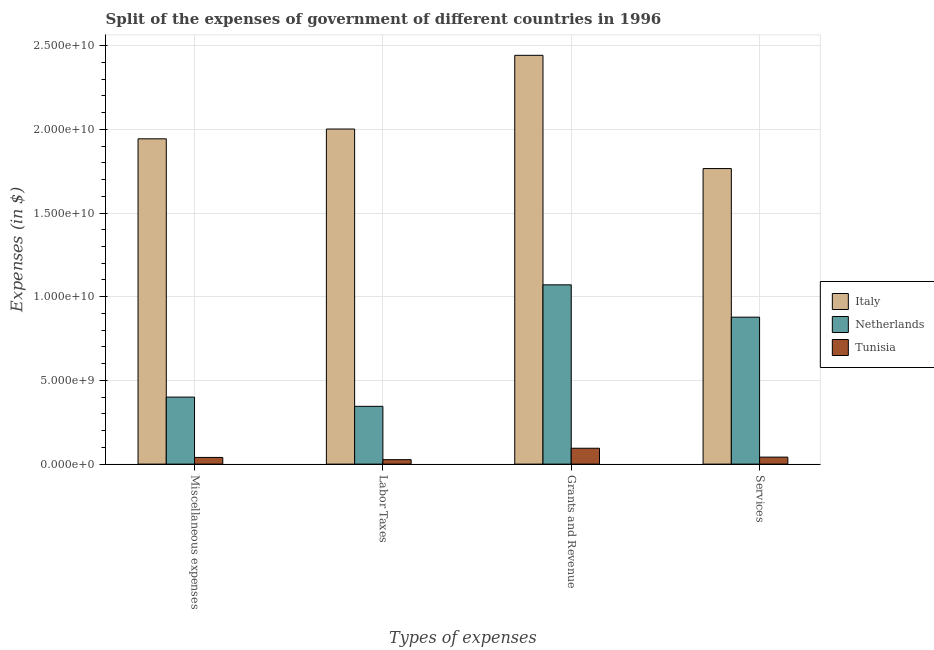Are the number of bars on each tick of the X-axis equal?
Give a very brief answer. Yes. What is the label of the 3rd group of bars from the left?
Your answer should be compact. Grants and Revenue. What is the amount spent on services in Italy?
Offer a terse response. 1.77e+1. Across all countries, what is the maximum amount spent on labor taxes?
Offer a terse response. 2.00e+1. Across all countries, what is the minimum amount spent on labor taxes?
Your response must be concise. 2.66e+08. In which country was the amount spent on grants and revenue minimum?
Give a very brief answer. Tunisia. What is the total amount spent on miscellaneous expenses in the graph?
Your answer should be very brief. 2.38e+1. What is the difference between the amount spent on grants and revenue in Tunisia and that in Netherlands?
Your answer should be compact. -9.76e+09. What is the difference between the amount spent on services in Tunisia and the amount spent on labor taxes in Italy?
Offer a very short reply. -1.96e+1. What is the average amount spent on services per country?
Keep it short and to the point. 8.95e+09. What is the difference between the amount spent on grants and revenue and amount spent on services in Italy?
Your response must be concise. 6.77e+09. In how many countries, is the amount spent on grants and revenue greater than 12000000000 $?
Ensure brevity in your answer.  1. What is the ratio of the amount spent on grants and revenue in Italy to that in Netherlands?
Provide a short and direct response. 2.28. Is the amount spent on services in Netherlands less than that in Italy?
Provide a short and direct response. Yes. Is the difference between the amount spent on labor taxes in Italy and Tunisia greater than the difference between the amount spent on miscellaneous expenses in Italy and Tunisia?
Give a very brief answer. Yes. What is the difference between the highest and the second highest amount spent on miscellaneous expenses?
Offer a very short reply. 1.54e+1. What is the difference between the highest and the lowest amount spent on grants and revenue?
Your answer should be very brief. 2.35e+1. Is the sum of the amount spent on services in Netherlands and Tunisia greater than the maximum amount spent on labor taxes across all countries?
Give a very brief answer. No. Is it the case that in every country, the sum of the amount spent on miscellaneous expenses and amount spent on grants and revenue is greater than the sum of amount spent on services and amount spent on labor taxes?
Offer a terse response. No. What does the 1st bar from the left in Services represents?
Ensure brevity in your answer.  Italy. What does the 2nd bar from the right in Grants and Revenue represents?
Provide a short and direct response. Netherlands. How many bars are there?
Your answer should be compact. 12. Are all the bars in the graph horizontal?
Ensure brevity in your answer.  No. What is the difference between two consecutive major ticks on the Y-axis?
Offer a very short reply. 5.00e+09. Are the values on the major ticks of Y-axis written in scientific E-notation?
Offer a terse response. Yes. Does the graph contain grids?
Provide a short and direct response. Yes. Where does the legend appear in the graph?
Provide a succinct answer. Center right. How many legend labels are there?
Provide a succinct answer. 3. What is the title of the graph?
Your answer should be compact. Split of the expenses of government of different countries in 1996. What is the label or title of the X-axis?
Ensure brevity in your answer.  Types of expenses. What is the label or title of the Y-axis?
Offer a very short reply. Expenses (in $). What is the Expenses (in $) of Italy in Miscellaneous expenses?
Provide a short and direct response. 1.94e+1. What is the Expenses (in $) of Netherlands in Miscellaneous expenses?
Make the answer very short. 4.00e+09. What is the Expenses (in $) of Tunisia in Miscellaneous expenses?
Give a very brief answer. 4.00e+08. What is the Expenses (in $) in Italy in Labor Taxes?
Make the answer very short. 2.00e+1. What is the Expenses (in $) in Netherlands in Labor Taxes?
Provide a succinct answer. 3.45e+09. What is the Expenses (in $) of Tunisia in Labor Taxes?
Give a very brief answer. 2.66e+08. What is the Expenses (in $) in Italy in Grants and Revenue?
Your answer should be very brief. 2.44e+1. What is the Expenses (in $) in Netherlands in Grants and Revenue?
Provide a short and direct response. 1.07e+1. What is the Expenses (in $) of Tunisia in Grants and Revenue?
Make the answer very short. 9.49e+08. What is the Expenses (in $) in Italy in Services?
Keep it short and to the point. 1.77e+1. What is the Expenses (in $) in Netherlands in Services?
Give a very brief answer. 8.78e+09. What is the Expenses (in $) in Tunisia in Services?
Provide a succinct answer. 4.18e+08. Across all Types of expenses, what is the maximum Expenses (in $) in Italy?
Your response must be concise. 2.44e+1. Across all Types of expenses, what is the maximum Expenses (in $) of Netherlands?
Your answer should be compact. 1.07e+1. Across all Types of expenses, what is the maximum Expenses (in $) of Tunisia?
Your answer should be very brief. 9.49e+08. Across all Types of expenses, what is the minimum Expenses (in $) in Italy?
Offer a terse response. 1.77e+1. Across all Types of expenses, what is the minimum Expenses (in $) in Netherlands?
Ensure brevity in your answer.  3.45e+09. Across all Types of expenses, what is the minimum Expenses (in $) of Tunisia?
Offer a very short reply. 2.66e+08. What is the total Expenses (in $) of Italy in the graph?
Your response must be concise. 8.15e+1. What is the total Expenses (in $) in Netherlands in the graph?
Provide a short and direct response. 2.69e+1. What is the total Expenses (in $) of Tunisia in the graph?
Provide a short and direct response. 2.03e+09. What is the difference between the Expenses (in $) of Italy in Miscellaneous expenses and that in Labor Taxes?
Keep it short and to the point. -5.85e+08. What is the difference between the Expenses (in $) in Netherlands in Miscellaneous expenses and that in Labor Taxes?
Ensure brevity in your answer.  5.51e+08. What is the difference between the Expenses (in $) in Tunisia in Miscellaneous expenses and that in Labor Taxes?
Offer a very short reply. 1.34e+08. What is the difference between the Expenses (in $) in Italy in Miscellaneous expenses and that in Grants and Revenue?
Give a very brief answer. -4.99e+09. What is the difference between the Expenses (in $) in Netherlands in Miscellaneous expenses and that in Grants and Revenue?
Offer a terse response. -6.71e+09. What is the difference between the Expenses (in $) in Tunisia in Miscellaneous expenses and that in Grants and Revenue?
Give a very brief answer. -5.49e+08. What is the difference between the Expenses (in $) in Italy in Miscellaneous expenses and that in Services?
Your response must be concise. 1.78e+09. What is the difference between the Expenses (in $) of Netherlands in Miscellaneous expenses and that in Services?
Offer a very short reply. -4.78e+09. What is the difference between the Expenses (in $) in Tunisia in Miscellaneous expenses and that in Services?
Provide a succinct answer. -1.86e+07. What is the difference between the Expenses (in $) in Italy in Labor Taxes and that in Grants and Revenue?
Your response must be concise. -4.40e+09. What is the difference between the Expenses (in $) of Netherlands in Labor Taxes and that in Grants and Revenue?
Your response must be concise. -7.26e+09. What is the difference between the Expenses (in $) in Tunisia in Labor Taxes and that in Grants and Revenue?
Offer a terse response. -6.83e+08. What is the difference between the Expenses (in $) in Italy in Labor Taxes and that in Services?
Ensure brevity in your answer.  2.36e+09. What is the difference between the Expenses (in $) of Netherlands in Labor Taxes and that in Services?
Provide a short and direct response. -5.33e+09. What is the difference between the Expenses (in $) in Tunisia in Labor Taxes and that in Services?
Make the answer very short. -1.52e+08. What is the difference between the Expenses (in $) in Italy in Grants and Revenue and that in Services?
Keep it short and to the point. 6.77e+09. What is the difference between the Expenses (in $) in Netherlands in Grants and Revenue and that in Services?
Offer a very short reply. 1.93e+09. What is the difference between the Expenses (in $) of Tunisia in Grants and Revenue and that in Services?
Make the answer very short. 5.30e+08. What is the difference between the Expenses (in $) in Italy in Miscellaneous expenses and the Expenses (in $) in Netherlands in Labor Taxes?
Your answer should be very brief. 1.60e+1. What is the difference between the Expenses (in $) in Italy in Miscellaneous expenses and the Expenses (in $) in Tunisia in Labor Taxes?
Your answer should be compact. 1.92e+1. What is the difference between the Expenses (in $) in Netherlands in Miscellaneous expenses and the Expenses (in $) in Tunisia in Labor Taxes?
Make the answer very short. 3.74e+09. What is the difference between the Expenses (in $) in Italy in Miscellaneous expenses and the Expenses (in $) in Netherlands in Grants and Revenue?
Provide a short and direct response. 8.72e+09. What is the difference between the Expenses (in $) in Italy in Miscellaneous expenses and the Expenses (in $) in Tunisia in Grants and Revenue?
Give a very brief answer. 1.85e+1. What is the difference between the Expenses (in $) in Netherlands in Miscellaneous expenses and the Expenses (in $) in Tunisia in Grants and Revenue?
Your response must be concise. 3.05e+09. What is the difference between the Expenses (in $) in Italy in Miscellaneous expenses and the Expenses (in $) in Netherlands in Services?
Your response must be concise. 1.07e+1. What is the difference between the Expenses (in $) in Italy in Miscellaneous expenses and the Expenses (in $) in Tunisia in Services?
Make the answer very short. 1.90e+1. What is the difference between the Expenses (in $) of Netherlands in Miscellaneous expenses and the Expenses (in $) of Tunisia in Services?
Make the answer very short. 3.58e+09. What is the difference between the Expenses (in $) in Italy in Labor Taxes and the Expenses (in $) in Netherlands in Grants and Revenue?
Provide a short and direct response. 9.31e+09. What is the difference between the Expenses (in $) in Italy in Labor Taxes and the Expenses (in $) in Tunisia in Grants and Revenue?
Your answer should be compact. 1.91e+1. What is the difference between the Expenses (in $) of Netherlands in Labor Taxes and the Expenses (in $) of Tunisia in Grants and Revenue?
Provide a short and direct response. 2.50e+09. What is the difference between the Expenses (in $) of Italy in Labor Taxes and the Expenses (in $) of Netherlands in Services?
Your response must be concise. 1.12e+1. What is the difference between the Expenses (in $) in Italy in Labor Taxes and the Expenses (in $) in Tunisia in Services?
Offer a very short reply. 1.96e+1. What is the difference between the Expenses (in $) of Netherlands in Labor Taxes and the Expenses (in $) of Tunisia in Services?
Your answer should be very brief. 3.03e+09. What is the difference between the Expenses (in $) in Italy in Grants and Revenue and the Expenses (in $) in Netherlands in Services?
Your response must be concise. 1.56e+1. What is the difference between the Expenses (in $) of Italy in Grants and Revenue and the Expenses (in $) of Tunisia in Services?
Keep it short and to the point. 2.40e+1. What is the difference between the Expenses (in $) of Netherlands in Grants and Revenue and the Expenses (in $) of Tunisia in Services?
Your answer should be very brief. 1.03e+1. What is the average Expenses (in $) of Italy per Types of expenses?
Your answer should be very brief. 2.04e+1. What is the average Expenses (in $) of Netherlands per Types of expenses?
Offer a very short reply. 6.74e+09. What is the average Expenses (in $) of Tunisia per Types of expenses?
Provide a succinct answer. 5.08e+08. What is the difference between the Expenses (in $) of Italy and Expenses (in $) of Netherlands in Miscellaneous expenses?
Give a very brief answer. 1.54e+1. What is the difference between the Expenses (in $) of Italy and Expenses (in $) of Tunisia in Miscellaneous expenses?
Give a very brief answer. 1.90e+1. What is the difference between the Expenses (in $) of Netherlands and Expenses (in $) of Tunisia in Miscellaneous expenses?
Your answer should be very brief. 3.60e+09. What is the difference between the Expenses (in $) in Italy and Expenses (in $) in Netherlands in Labor Taxes?
Provide a short and direct response. 1.66e+1. What is the difference between the Expenses (in $) in Italy and Expenses (in $) in Tunisia in Labor Taxes?
Give a very brief answer. 1.98e+1. What is the difference between the Expenses (in $) of Netherlands and Expenses (in $) of Tunisia in Labor Taxes?
Keep it short and to the point. 3.19e+09. What is the difference between the Expenses (in $) of Italy and Expenses (in $) of Netherlands in Grants and Revenue?
Offer a very short reply. 1.37e+1. What is the difference between the Expenses (in $) of Italy and Expenses (in $) of Tunisia in Grants and Revenue?
Provide a succinct answer. 2.35e+1. What is the difference between the Expenses (in $) of Netherlands and Expenses (in $) of Tunisia in Grants and Revenue?
Provide a short and direct response. 9.76e+09. What is the difference between the Expenses (in $) in Italy and Expenses (in $) in Netherlands in Services?
Offer a very short reply. 8.88e+09. What is the difference between the Expenses (in $) in Italy and Expenses (in $) in Tunisia in Services?
Your response must be concise. 1.72e+1. What is the difference between the Expenses (in $) of Netherlands and Expenses (in $) of Tunisia in Services?
Provide a succinct answer. 8.36e+09. What is the ratio of the Expenses (in $) in Italy in Miscellaneous expenses to that in Labor Taxes?
Provide a short and direct response. 0.97. What is the ratio of the Expenses (in $) in Netherlands in Miscellaneous expenses to that in Labor Taxes?
Your response must be concise. 1.16. What is the ratio of the Expenses (in $) of Tunisia in Miscellaneous expenses to that in Labor Taxes?
Provide a short and direct response. 1.5. What is the ratio of the Expenses (in $) of Italy in Miscellaneous expenses to that in Grants and Revenue?
Your answer should be compact. 0.8. What is the ratio of the Expenses (in $) in Netherlands in Miscellaneous expenses to that in Grants and Revenue?
Ensure brevity in your answer.  0.37. What is the ratio of the Expenses (in $) of Tunisia in Miscellaneous expenses to that in Grants and Revenue?
Offer a terse response. 0.42. What is the ratio of the Expenses (in $) of Italy in Miscellaneous expenses to that in Services?
Offer a very short reply. 1.1. What is the ratio of the Expenses (in $) of Netherlands in Miscellaneous expenses to that in Services?
Make the answer very short. 0.46. What is the ratio of the Expenses (in $) of Tunisia in Miscellaneous expenses to that in Services?
Your response must be concise. 0.96. What is the ratio of the Expenses (in $) of Italy in Labor Taxes to that in Grants and Revenue?
Offer a very short reply. 0.82. What is the ratio of the Expenses (in $) of Netherlands in Labor Taxes to that in Grants and Revenue?
Offer a terse response. 0.32. What is the ratio of the Expenses (in $) of Tunisia in Labor Taxes to that in Grants and Revenue?
Provide a short and direct response. 0.28. What is the ratio of the Expenses (in $) in Italy in Labor Taxes to that in Services?
Make the answer very short. 1.13. What is the ratio of the Expenses (in $) in Netherlands in Labor Taxes to that in Services?
Ensure brevity in your answer.  0.39. What is the ratio of the Expenses (in $) in Tunisia in Labor Taxes to that in Services?
Provide a short and direct response. 0.64. What is the ratio of the Expenses (in $) in Italy in Grants and Revenue to that in Services?
Offer a very short reply. 1.38. What is the ratio of the Expenses (in $) of Netherlands in Grants and Revenue to that in Services?
Keep it short and to the point. 1.22. What is the ratio of the Expenses (in $) in Tunisia in Grants and Revenue to that in Services?
Keep it short and to the point. 2.27. What is the difference between the highest and the second highest Expenses (in $) in Italy?
Ensure brevity in your answer.  4.40e+09. What is the difference between the highest and the second highest Expenses (in $) of Netherlands?
Keep it short and to the point. 1.93e+09. What is the difference between the highest and the second highest Expenses (in $) of Tunisia?
Provide a succinct answer. 5.30e+08. What is the difference between the highest and the lowest Expenses (in $) in Italy?
Your response must be concise. 6.77e+09. What is the difference between the highest and the lowest Expenses (in $) in Netherlands?
Offer a terse response. 7.26e+09. What is the difference between the highest and the lowest Expenses (in $) in Tunisia?
Your answer should be compact. 6.83e+08. 